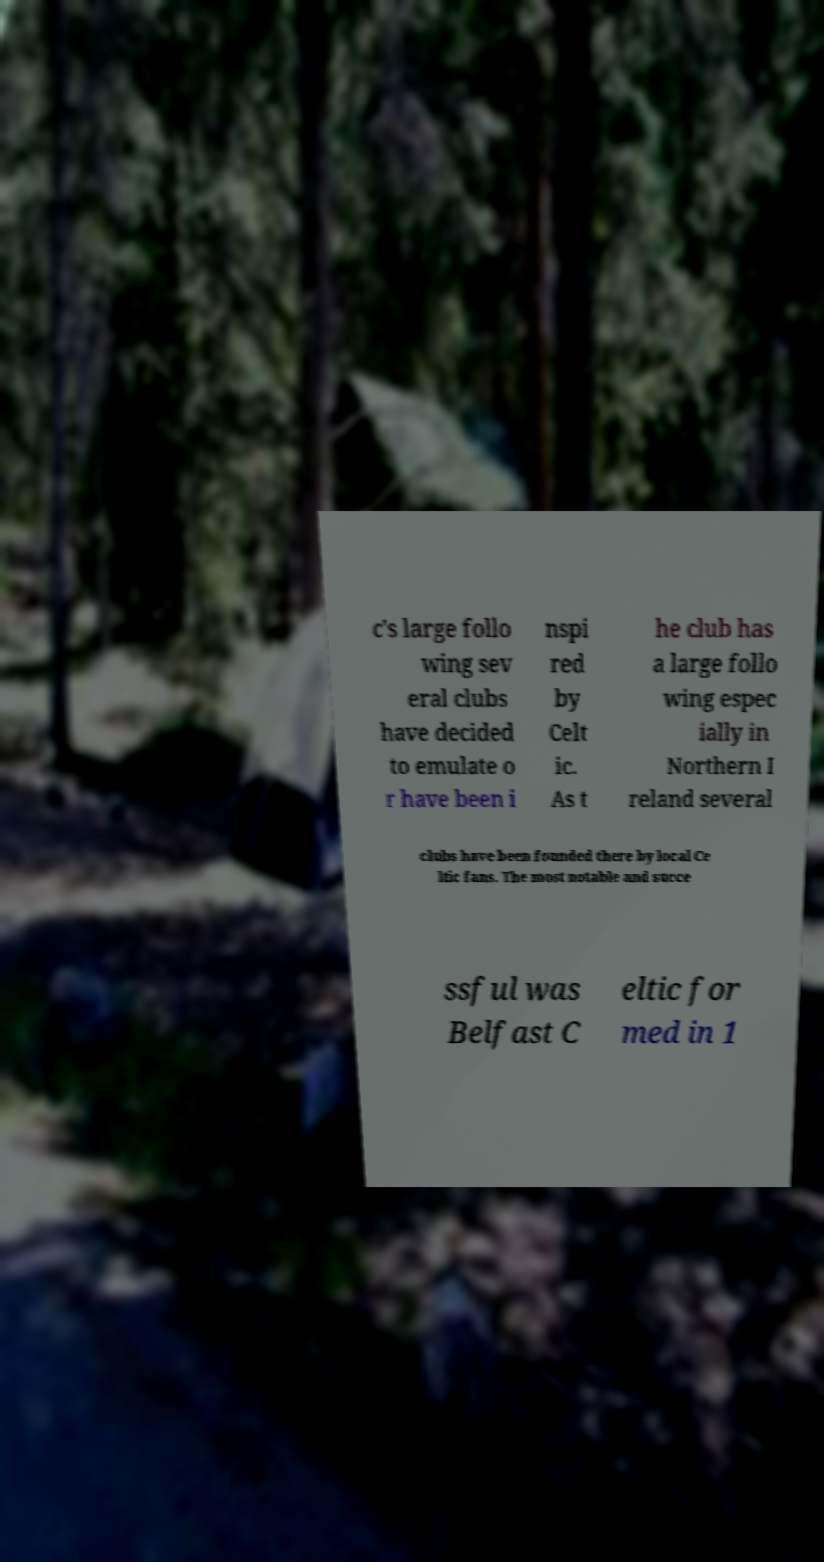What messages or text are displayed in this image? I need them in a readable, typed format. c's large follo wing sev eral clubs have decided to emulate o r have been i nspi red by Celt ic. As t he club has a large follo wing espec ially in Northern I reland several clubs have been founded there by local Ce ltic fans. The most notable and succe ssful was Belfast C eltic for med in 1 